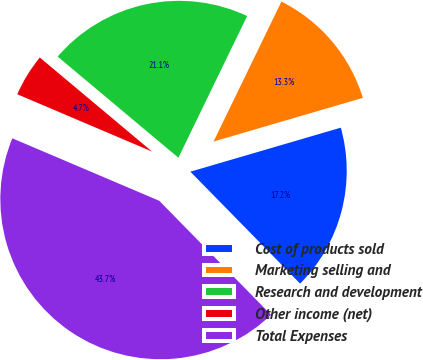<chart> <loc_0><loc_0><loc_500><loc_500><pie_chart><fcel>Cost of products sold<fcel>Marketing selling and<fcel>Research and development<fcel>Other income (net)<fcel>Total Expenses<nl><fcel>17.19%<fcel>13.28%<fcel>21.09%<fcel>4.7%<fcel>43.74%<nl></chart> 